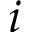<formula> <loc_0><loc_0><loc_500><loc_500>i</formula> 